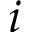<formula> <loc_0><loc_0><loc_500><loc_500>i</formula> 